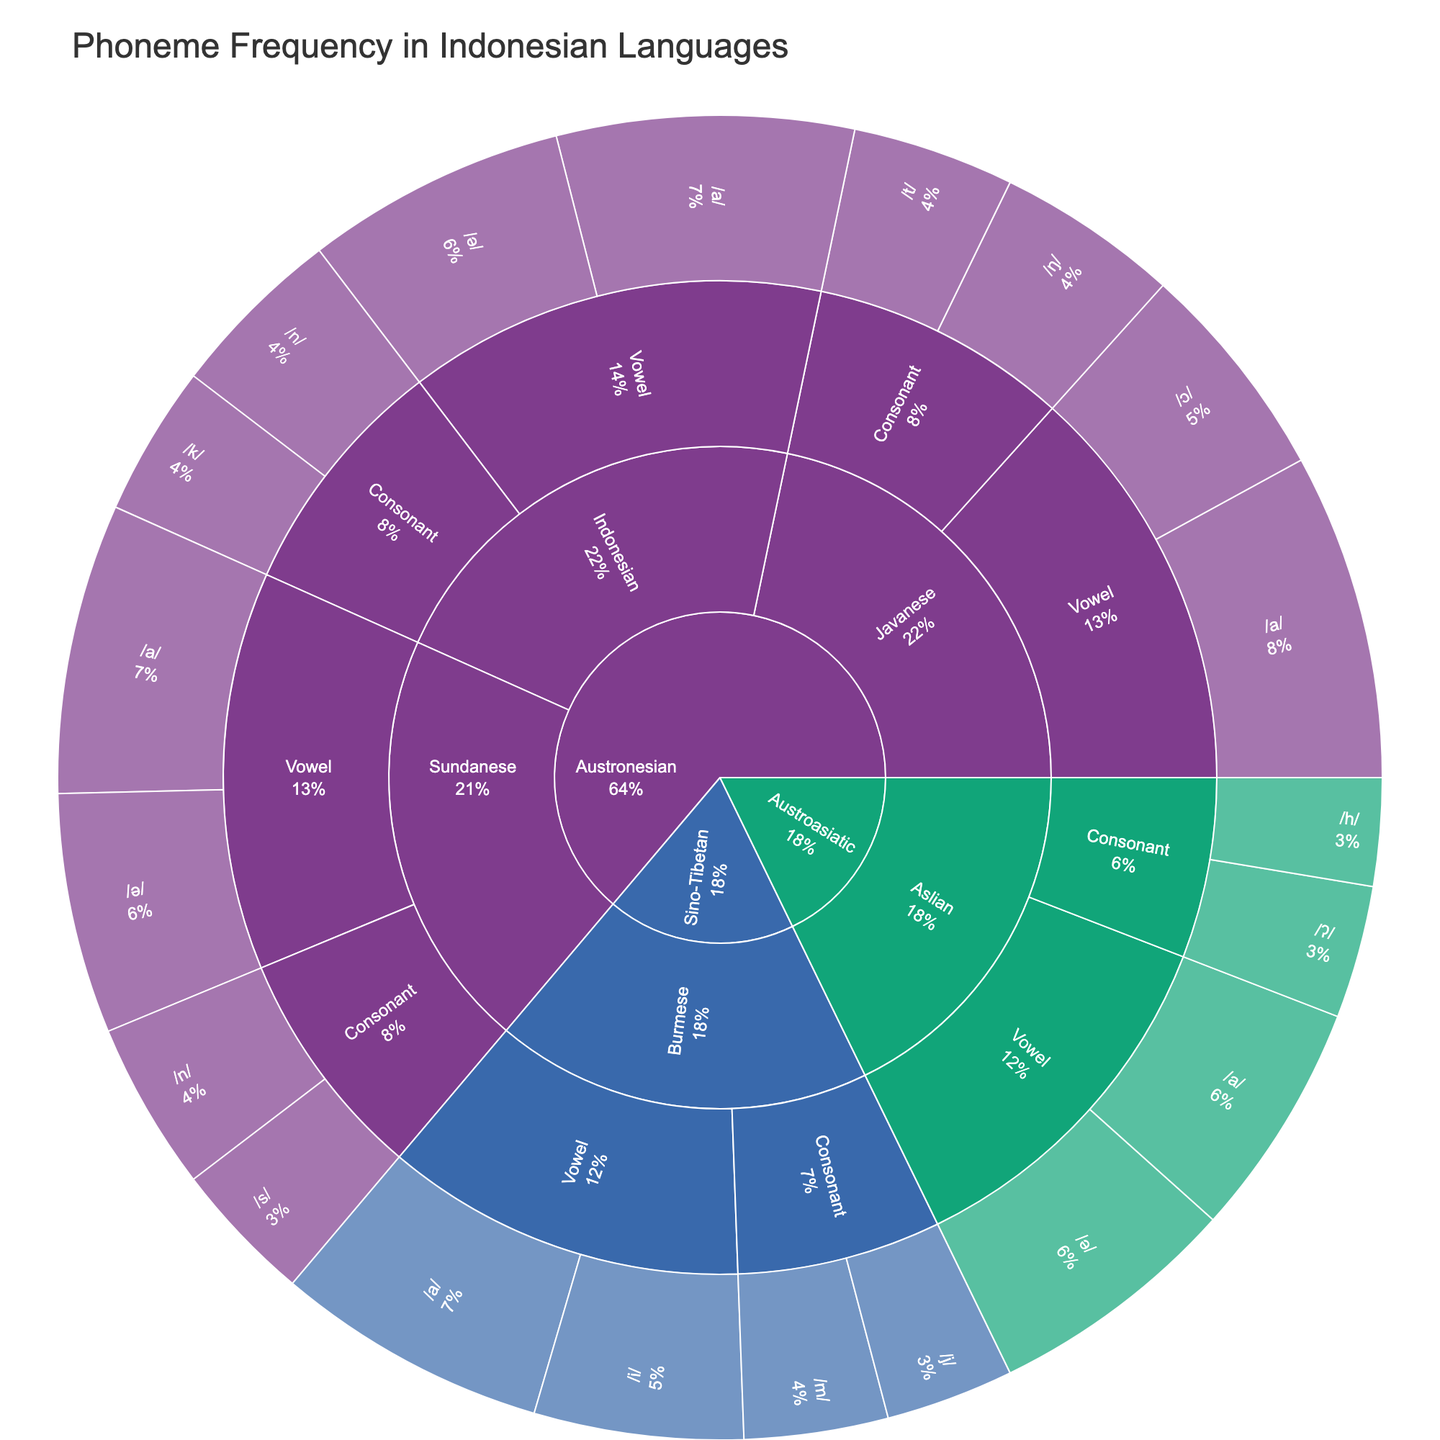What is the title of the sunburst plot? The title is located at the top of the plot and indicates what the figure is about.
Answer: "Phoneme Frequency in Indonesian Languages" In which language is the phoneme /a/ the most frequent? To answer this, look at the segments representing the vowel /a/ in each language and compare their sizes or percentages.
Answer: Javanese Which language family has the vowel /ə/ with the lowest frequency? Examine the segments for the vowel /ə/ in each language within the different language families and find the one with the smallest segment or the lowest percentage.
Answer: Austroasiatic What is the total frequency of the consonant /n/ across all languages? Sum the frequencies of the consonant /n/ in each language as shown in the plot. In this case, Indonesian (7.8) and Sundanese (7.5).
Answer: 15.3 Which phoneme has a higher frequency in Javanese, /ŋ/ or /t/? Compare the sizes or percentages of the segments for the consonants /ŋ/ and /t/ in the Javanese language.
Answer: /ŋ/ How does the frequency of vowels in Indonesian compare to consonants in Indonesian? Add up the frequencies of all vowels and consonants in Indonesian and compare the totals. Vowels: /a/ (13.2) + /ə/ (11.6) = 24.8; Consonants: /n/ (7.8) + /k/ (6.7) = 14.5.
Answer: Vowels are more frequent What percentage of the total does the vowel /a/ in Burmese contribute? Locate the segment representing the vowel /a/ in Burmese and look at the percentage it occupies out of the total plot.
Answer: Find the exact percentage entry on the plot Which phoneme type has a higher overall frequency in the Austronesian language family, vowels or consonants? Summing the frequencies of all vowels and consonants in Austronesian languages and comparing the totals will give the answer.
Answer: Vowels How does the frequency of the vowel /i/ in Burmese compare to the vowel /ɔ/ in Javanese? Compare the size or percentage of the segment for the vowel /i/ in Burmese (9.3) and /ɔ/ in Javanese (9.8).
Answer: /ɔ/ in Javanese Is the consonant /m/ more frequent in Burmese or the consonant /h/ in Aslian? Compare the sizes or percentages of the segments for the consonant /m/ in Burmese and /h/ in Aslian.
Answer: /m/ in Burmese 